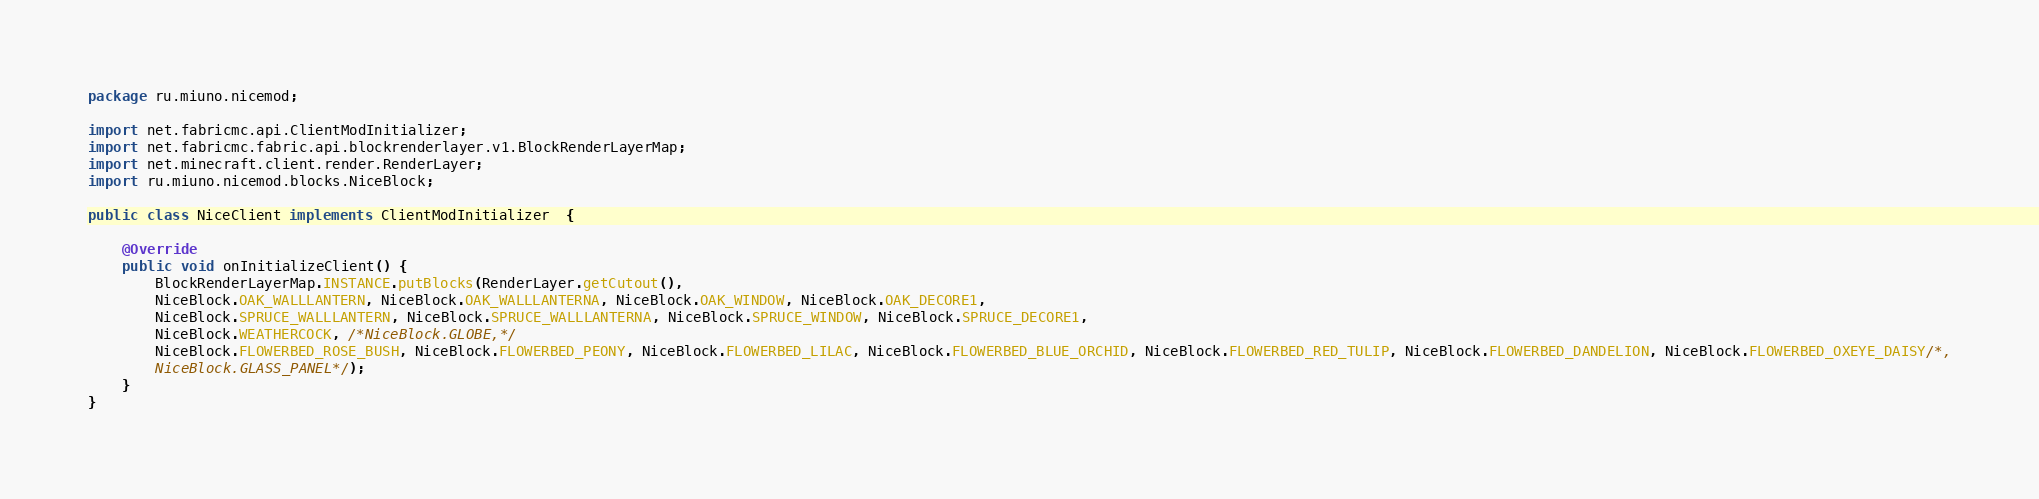<code> <loc_0><loc_0><loc_500><loc_500><_Java_>package ru.miuno.nicemod;

import net.fabricmc.api.ClientModInitializer;
import net.fabricmc.fabric.api.blockrenderlayer.v1.BlockRenderLayerMap;
import net.minecraft.client.render.RenderLayer;
import ru.miuno.nicemod.blocks.NiceBlock;

public class NiceClient implements ClientModInitializer  {

	@Override
	public void onInitializeClient() {
        BlockRenderLayerMap.INSTANCE.putBlocks(RenderLayer.getCutout(),
		NiceBlock.OAK_WALLLANTERN, NiceBlock.OAK_WALLLANTERNA, NiceBlock.OAK_WINDOW, NiceBlock.OAK_DECORE1, 
		NiceBlock.SPRUCE_WALLLANTERN, NiceBlock.SPRUCE_WALLLANTERNA, NiceBlock.SPRUCE_WINDOW, NiceBlock.SPRUCE_DECORE1,
		NiceBlock.WEATHERCOCK, /*NiceBlock.GLOBE,*/
		NiceBlock.FLOWERBED_ROSE_BUSH, NiceBlock.FLOWERBED_PEONY, NiceBlock.FLOWERBED_LILAC, NiceBlock.FLOWERBED_BLUE_ORCHID, NiceBlock.FLOWERBED_RED_TULIP, NiceBlock.FLOWERBED_DANDELION, NiceBlock.FLOWERBED_OXEYE_DAISY/*,
		NiceBlock.GLASS_PANEL*/);
	}
}</code> 